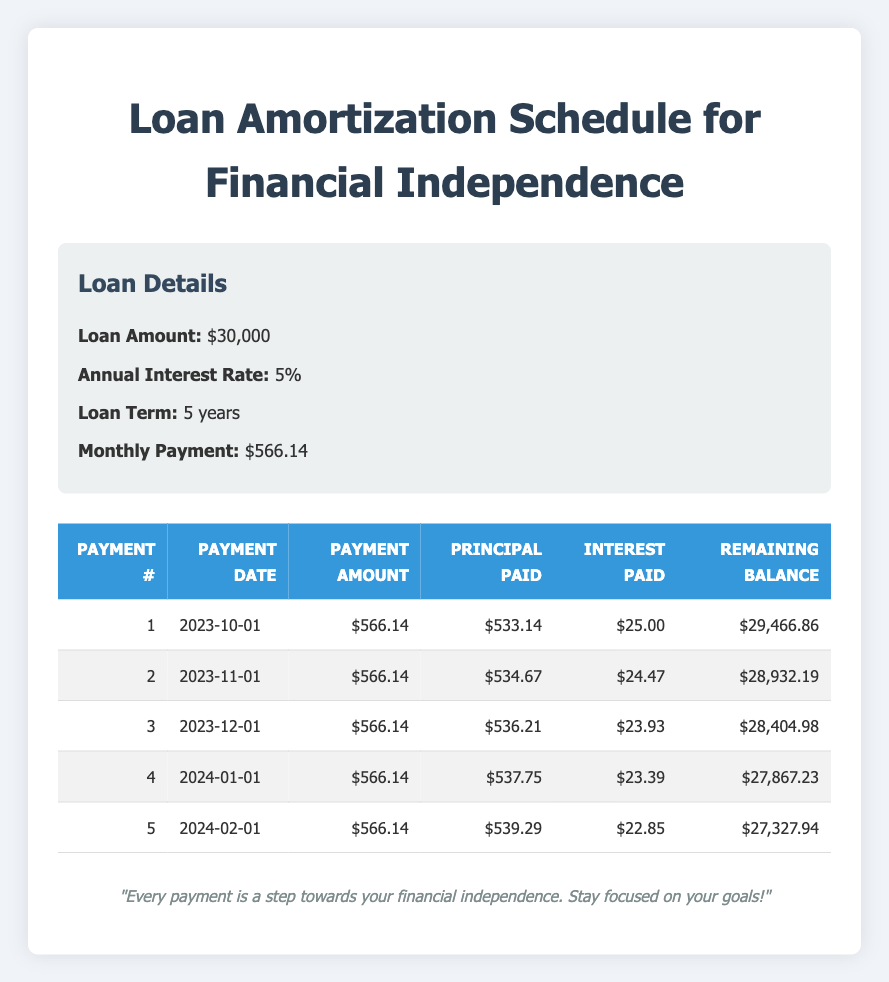What is the total amount paid after the first month? The payment amount for the first month is $566.14. Therefore, after one month, the total paid is simply this amount.
Answer: 566.14 How much principal was paid in the second month? From the table, the principal paid in the second month (payment number 2) is $534.67.
Answer: 534.67 Is the interest paid in the third month less than in the first month? The interest paid in the third month is $23.93, and in the first month, it was $25.00. Since $23.93 is less than $25.00, the statement is true.
Answer: Yes What is the remaining balance after the fourth payment? The remaining balance after the fourth payment is stated in the table as $27,867.23.
Answer: 27,867.23 What is the average monthly principal payment during the first five months? To find the average, sum the principal paid over the first five months: 533.14 + 534.67 + 536.21 + 537.75 + 539.29 = 2681.06. There are 5 months, so divide by 5: 2681.06 / 5 = 536.21.
Answer: 536.21 How much total interest was paid over the first five months? To find total interest, sum the interest amounts from each month's payment: 25.00 + 24.47 + 23.93 + 23.39 + 22.85 = 119.64.
Answer: 119.64 Is the payment amount consistent across all months? The payment amount for every month shown in the table is $566.14. Thus, it is consistent across all months.
Answer: Yes After two months, what is the total remaining balance? The table shows the remaining balance after the second payment is $28,932.19. Therefore, the total remaining balance after two months is this amount.
Answer: 28,932.19 What is the increase in principal payment from the first month to the fifth month? The principal payment in the first month is $533.14, and in the fifth month, it is $539.29. To find the increase, subtract: 539.29 - 533.14 = 6.15.
Answer: 6.15 